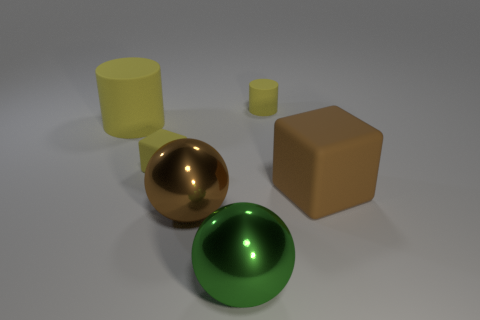How many yellow cylinders must be subtracted to get 1 yellow cylinders? 1 Subtract all spheres. How many objects are left? 4 Subtract 2 cylinders. How many cylinders are left? 0 Add 3 small yellow spheres. How many objects exist? 9 Subtract 0 cyan cylinders. How many objects are left? 6 Subtract all gray cylinders. Subtract all cyan spheres. How many cylinders are left? 2 Subtract all brown spheres. How many yellow cubes are left? 1 Subtract all balls. Subtract all tiny cylinders. How many objects are left? 3 Add 1 big blocks. How many big blocks are left? 2 Add 3 large green metal things. How many large green metal things exist? 4 